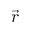<formula> <loc_0><loc_0><loc_500><loc_500>\vec { r }</formula> 